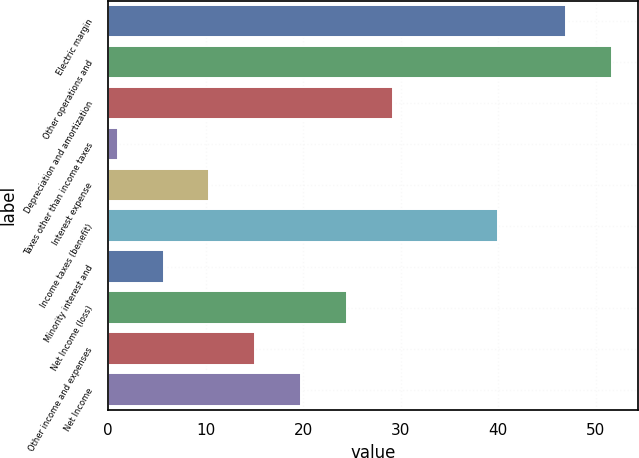Convert chart. <chart><loc_0><loc_0><loc_500><loc_500><bar_chart><fcel>Electric margin<fcel>Other operations and<fcel>Depreciation and amortization<fcel>Taxes other than income taxes<fcel>Interest expense<fcel>Income taxes (benefit)<fcel>Minority interest and<fcel>Net Income (loss)<fcel>Other income and expenses<fcel>Net Income<nl><fcel>47<fcel>51.7<fcel>29.2<fcel>1<fcel>10.4<fcel>40<fcel>5.7<fcel>24.5<fcel>15.1<fcel>19.8<nl></chart> 